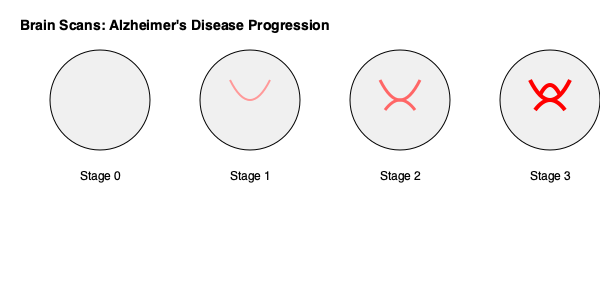Based on the brain scan patterns shown in the image, which stage of Alzheimer's disease is characterized by multiple, thick, red curved lines within the brain region? To answer this question, we need to analyze the patterns shown in each stage of the brain scans:

1. Stage 0 (Normal Brain): This scan shows a clear, white circle with no visible abnormalities.

2. Stage 1 (Early Stage): This scan shows a single, thin, light red curved line within the brain region.

3. Stage 2 (Moderate Stage): This scan displays two medium-thickness, darker red curved lines within the brain region.

4. Stage 3 (Advanced Stage): This scan is characterized by three thick, bright red curved lines within the brain region.

The question asks about multiple, thick, red curved lines. Among the four stages shown, only Stage 3 (Advanced Stage) exhibits these characteristics. It has the most pronounced and numerous red curves, indicating the most severe progression of Alzheimer's disease.

This pattern is consistent with advanced Alzheimer's disease, where significant brain atrophy and accumulation of amyloid plaques and neurofibrillary tangles would be expected, leading to more pronounced abnormalities on brain scans.
Answer: Stage 3 (Advanced Stage) 